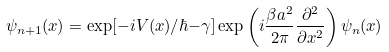<formula> <loc_0><loc_0><loc_500><loc_500>\psi _ { n + 1 } ( x ) = \exp [ - i V ( x ) / \hbar { - } \gamma ] \exp \left ( i \frac { \beta a ^ { 2 } } { 2 \pi } \frac { \partial ^ { 2 } } { \partial x ^ { 2 } } \right ) \psi _ { n } ( x )</formula> 